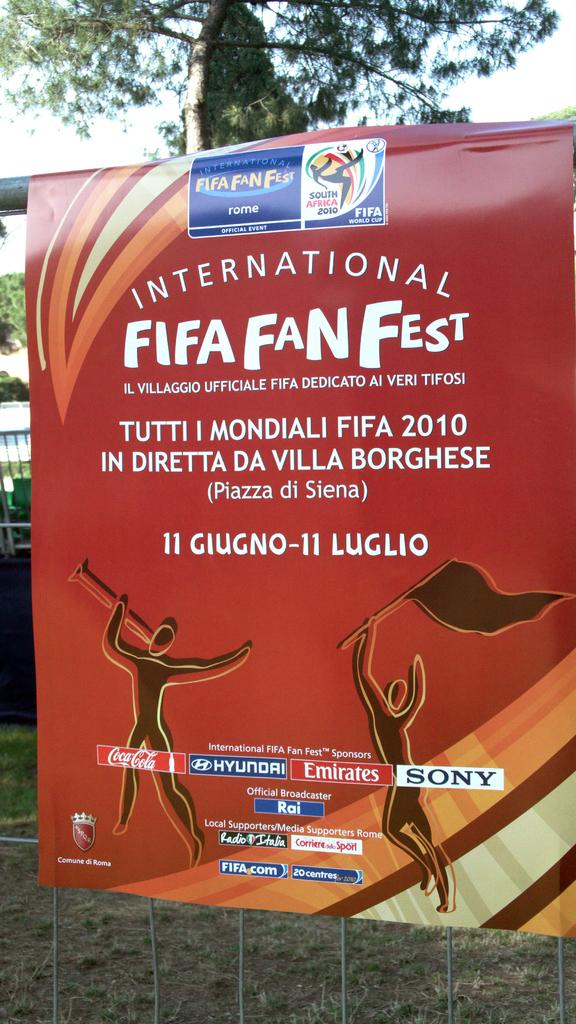<image>
Write a terse but informative summary of the picture. A small sign board displaying a logo for the Fifa Fan Fest. 